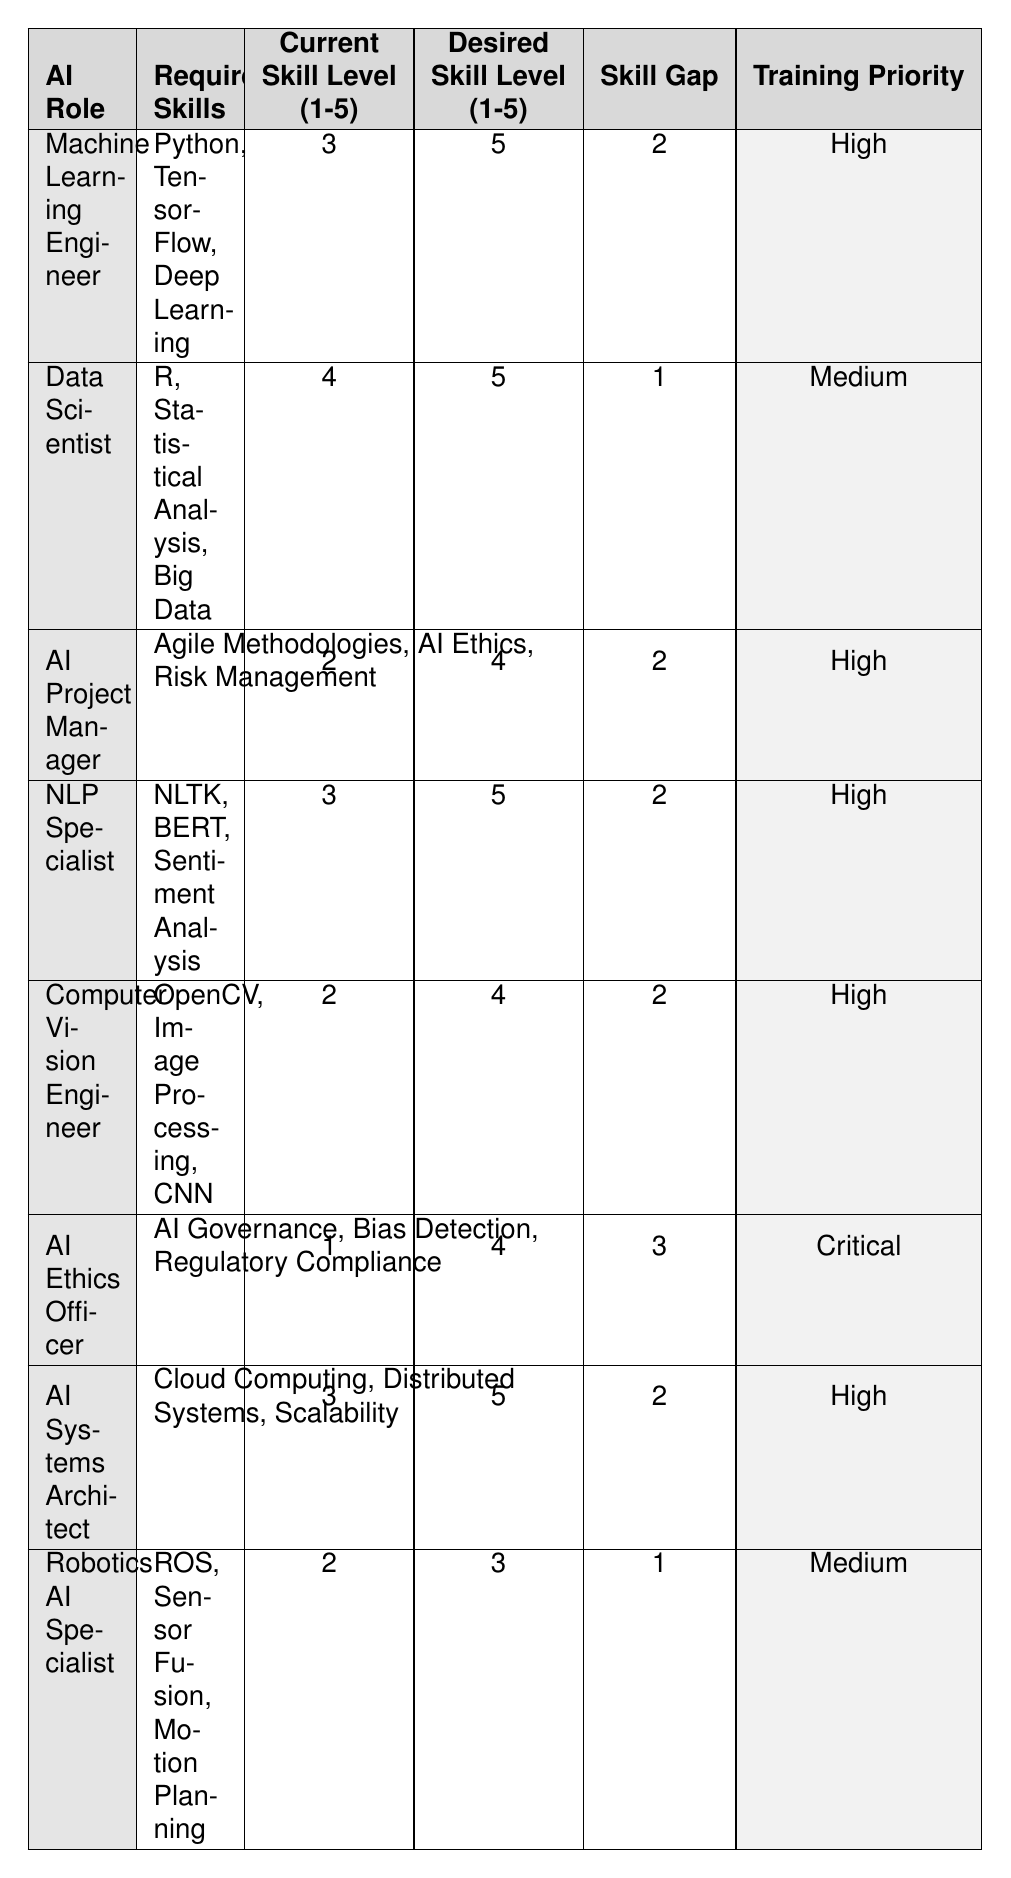What is the skill gap for the Data Scientist role? The skill gap is found in the "Skill Gap" column corresponding to the Data Scientist role. The value there is 1.
Answer: 1 Which AI role has the highest training priority? Looking at the "Training Priority" column, the AI Ethics Officer has the highest category, which is labeled as "Critical".
Answer: AI Ethics Officer How many roles have a skill gap of 2? Count the occurrences of the skill gap value of 2 in the "Skill Gap" column. There are four roles: Machine Learning Engineer, AI Project Manager, NLP Specialist, and AI Systems Architect.
Answer: 4 What is the average current skill level across all AI roles? To find the average current skill level, sum all the values from the "Current Skill Level" column: (3 + 4 + 2 + 3 + 2 + 1 + 3 + 2) = 20. There are 8 roles, so the average is 20/8 = 2.5.
Answer: 2.5 Is the current skill level for the Computer Vision Engineer role higher than that for the AI Ethics Officer? Compare the "Current Skill Level" for both roles: Computer Vision Engineer has a level of 2, while the AI Ethics Officer has a level of 1. Since 2 is greater than 1, the statement is true.
Answer: Yes What is the total number of skills required for the AI roles listed? Each AI role has a set of required skills. There are 8 AI roles listed, and each has a different number of required skills but summing them up yields 4+3+3+3+3+3+3+3 = 25 skills required.
Answer: 25 Which role has the least desirable skill level and what is the value? Check the "Desired Skill Level" column: the AI Ethics Officer has the lowest desired skill level, which is 4.
Answer: 4 Are there any roles that have the same skill gap? Look for duplicated skill gaps in the "Skill Gap" column: there are multiple roles with a skill gap of 2 (Machine Learning Engineer, AI Project Manager, NLP Specialist, AI Systems Architect).
Answer: Yes How many roles need a 'High' training priority? Count the roles in the "Training Priority" column with the value 'High'. There are 5 such roles: Machine Learning Engineer, AI Project Manager, NLP Specialist, Computer Vision Engineer, and AI Systems Architect.
Answer: 5 What is the difference between the desired skill level of the AI Ethics Officer and the Computer Vision Engineer? Find the value in the "Desired Skill Level" column for both roles: AI Ethics Officer is 4 and Computer Vision Engineer is 4. The difference is 4 - 4 = 0.
Answer: 0 